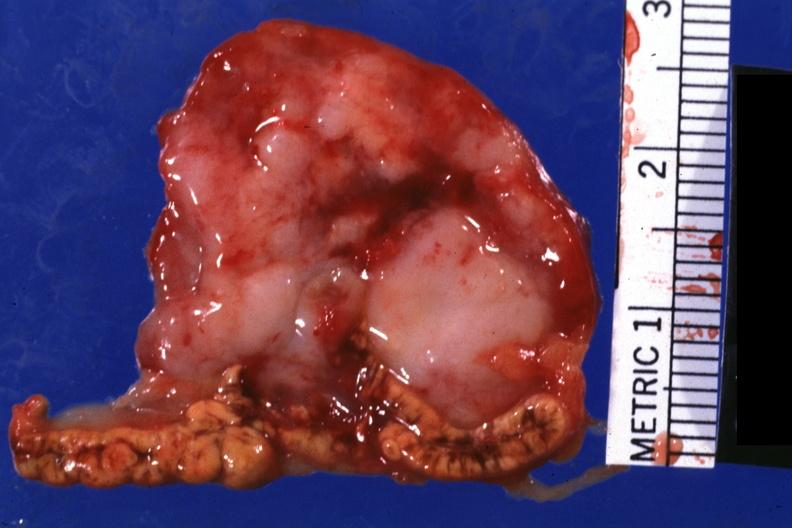does this image show close-up very good photo?
Answer the question using a single word or phrase. Yes 